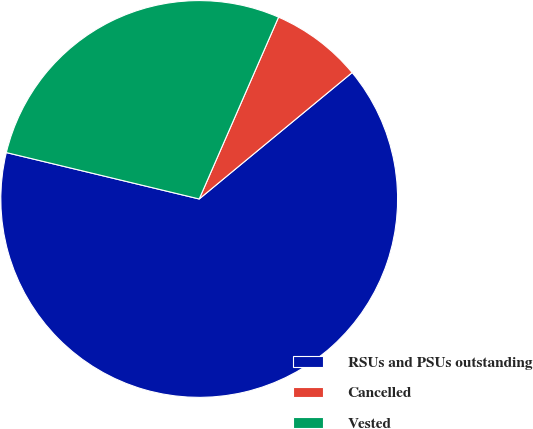<chart> <loc_0><loc_0><loc_500><loc_500><pie_chart><fcel>RSUs and PSUs outstanding<fcel>Cancelled<fcel>Vested<nl><fcel>64.75%<fcel>7.46%<fcel>27.79%<nl></chart> 